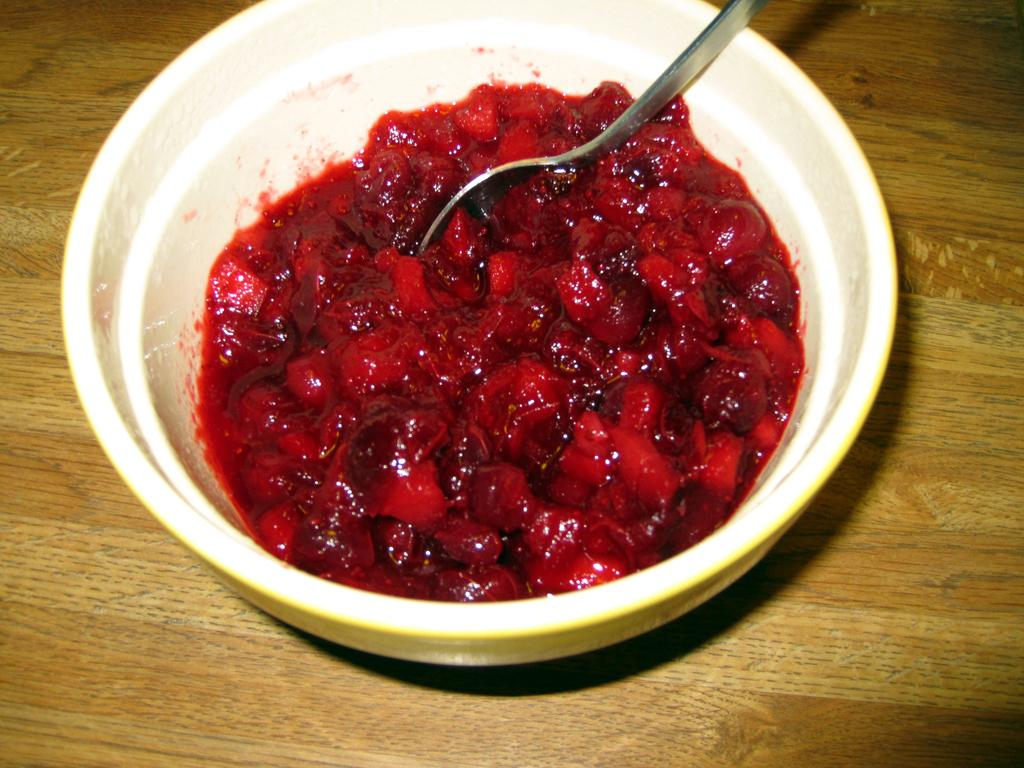What is the main piece of furniture in the image? There is a table in the image. What is placed on the table? There is a food item on the table. What utensil is in the bowl on the table? There is a spoon in a bowl on the table. What story is being told by the food item on the table? The food item on the table is not telling a story; it is simply a food item. 